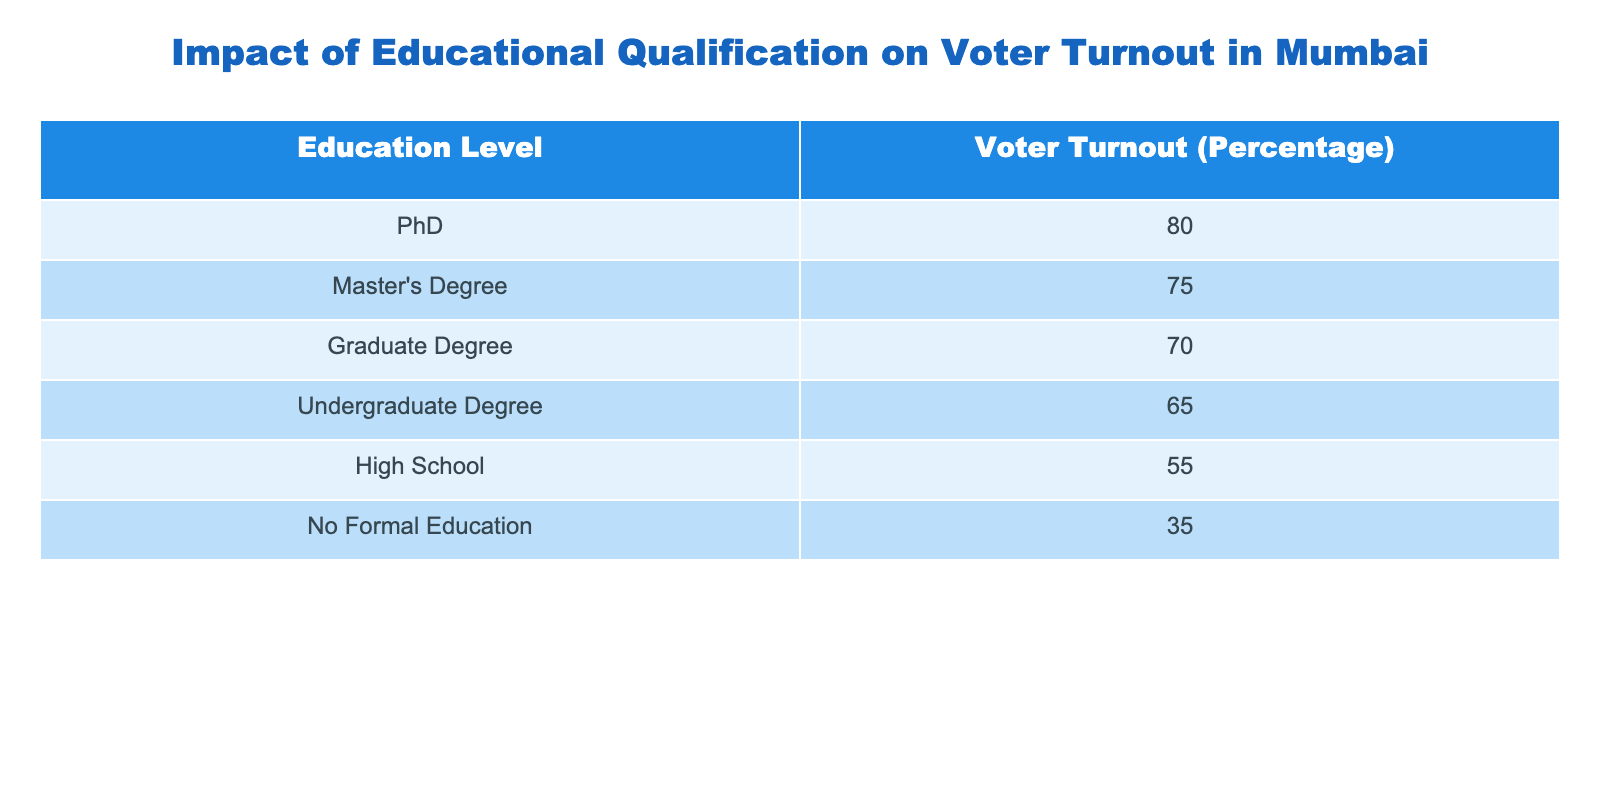What is the voter turnout percentage for individuals with no formal education? The table directly provides the voter turnout percentage for individuals with no formal education, which is listed as 35%.
Answer: 35 What is the difference in voter turnout between those with a Master's Degree and those with a High School education? The voter turnout for Master's Degree holders is 75%, while for those with a High School education, it is 55%. The difference is 75 - 55 = 20%.
Answer: 20% Is the voter turnout for individuals with an Undergraduate Degree higher than for those with a Graduate Degree? The table shows that the voter turnout for individuals with an Undergraduate Degree is 65% and for Graduate Degree holders is 70%. Since 65% is less than 70%, the statement is false.
Answer: No What is the average voter turnout percentage for all education levels listed? To find the average, we sum the percentages of all education levels: (80 + 75 + 70 + 65 + 55 + 35) = 380. There are 6 education levels, so the average is 380 / 6 = approximately 63.33%.
Answer: 63.33 Which education level has the highest voter turnout percentage? Looking through the table, the highest percentage is for individuals with a PhD, which is 80%.
Answer: PhD If you combine the voter turnout percentages of PhD and Master's Degree holders, what percentage do they represent together? The combined voter turnout for PhD (80%) and Master's Degree (75%) is 80 + 75 = 155%.
Answer: 155 What is the overall trend in voter turnout as educational qualification increases? By observing the percentages, we can see that as the educational qualification increases from No Formal Education to PhD, the turnout percentage consistently increases.
Answer: Increasing trend Is the voter turnout for graduates lower than that for individuals with a Master's Degree? According to the data, the voter turnout for Graduates is 70% and for Master's Degree holders is 75%. Since 70% is lower than 75%, the statement is true.
Answer: Yes 